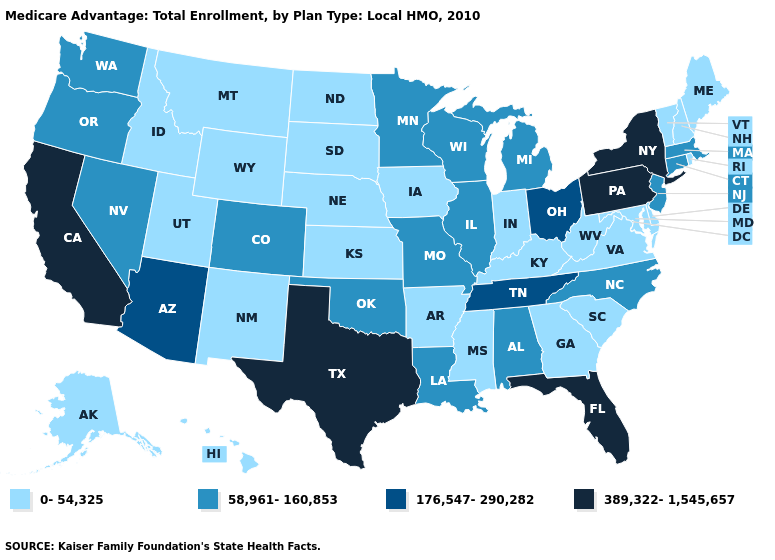Name the states that have a value in the range 389,322-1,545,657?
Keep it brief. California, Florida, New York, Pennsylvania, Texas. What is the value of Pennsylvania?
Give a very brief answer. 389,322-1,545,657. Does the map have missing data?
Concise answer only. No. Does the first symbol in the legend represent the smallest category?
Concise answer only. Yes. What is the value of Arkansas?
Concise answer only. 0-54,325. Among the states that border Arizona , which have the lowest value?
Short answer required. New Mexico, Utah. Among the states that border Utah , does Arizona have the highest value?
Concise answer only. Yes. Which states hav the highest value in the South?
Give a very brief answer. Florida, Texas. Among the states that border Rhode Island , which have the highest value?
Short answer required. Connecticut, Massachusetts. Does Wisconsin have the lowest value in the MidWest?
Keep it brief. No. Does Missouri have the highest value in the MidWest?
Short answer required. No. Which states have the lowest value in the USA?
Concise answer only. Alaska, Arkansas, Delaware, Georgia, Hawaii, Iowa, Idaho, Indiana, Kansas, Kentucky, Maryland, Maine, Mississippi, Montana, North Dakota, Nebraska, New Hampshire, New Mexico, Rhode Island, South Carolina, South Dakota, Utah, Virginia, Vermont, West Virginia, Wyoming. Name the states that have a value in the range 176,547-290,282?
Short answer required. Arizona, Ohio, Tennessee. What is the value of Oklahoma?
Short answer required. 58,961-160,853. What is the value of California?
Short answer required. 389,322-1,545,657. 